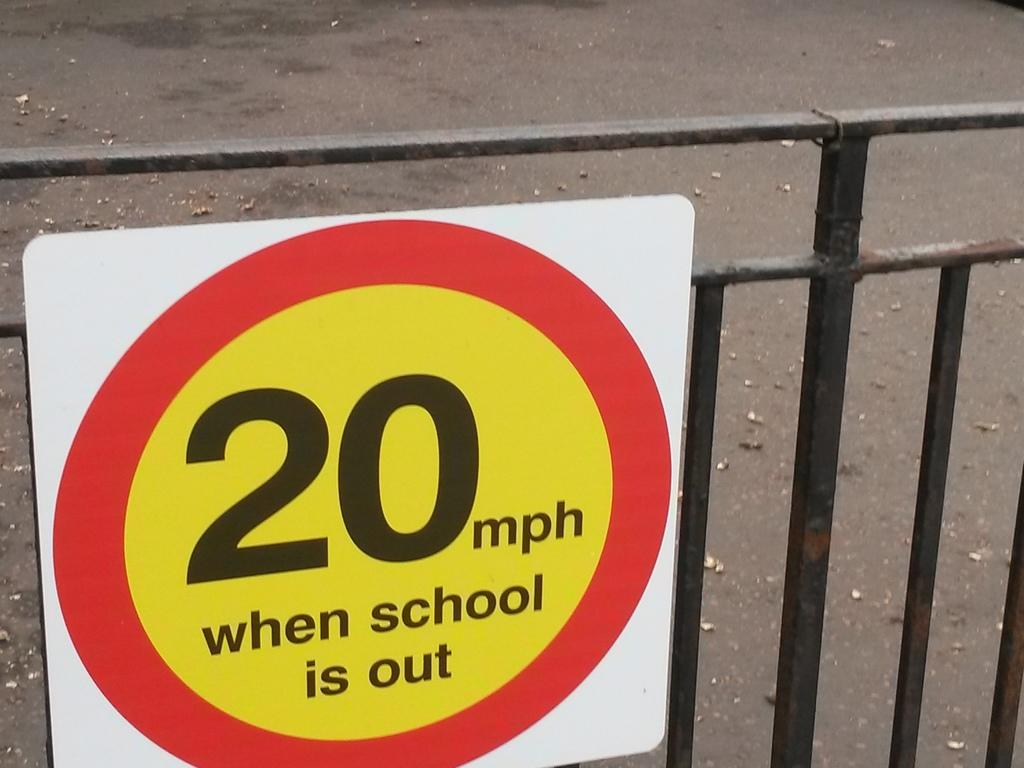<image>
Write a terse but informative summary of the picture. A red and yellow sign bares the message that the speed limit is 20 mph when school is out. 